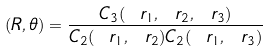<formula> <loc_0><loc_0><loc_500><loc_500>\L ( R , \theta ) = \frac { C _ { 3 } ( \ r _ { 1 } , \ r _ { 2 } , \ r _ { 3 } ) } { C _ { 2 } ( \ r _ { 1 } , \ r _ { 2 } ) C _ { 2 } ( \ r _ { 1 } , \ r _ { 3 } ) }</formula> 